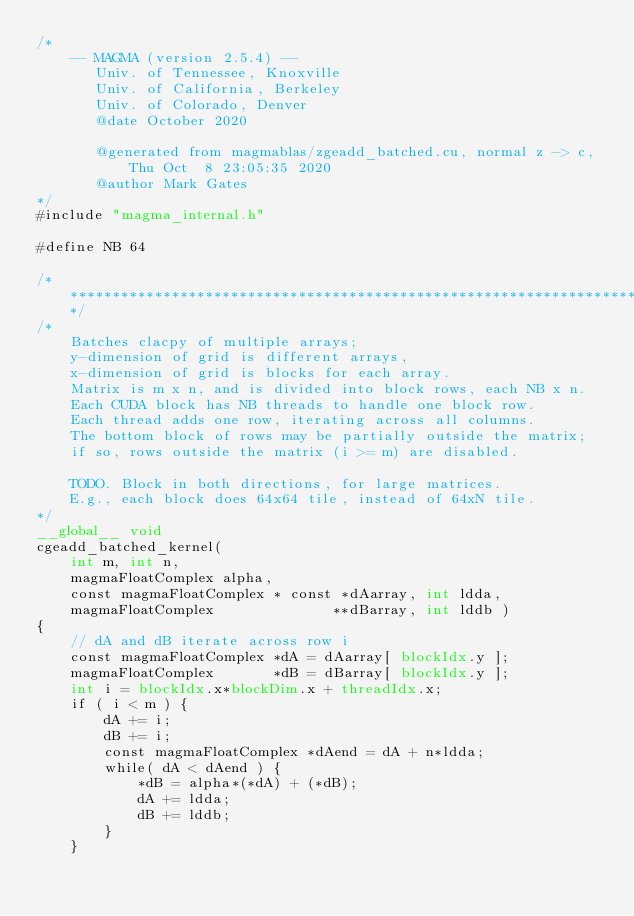Convert code to text. <code><loc_0><loc_0><loc_500><loc_500><_Cuda_>/*
    -- MAGMA (version 2.5.4) --
       Univ. of Tennessee, Knoxville
       Univ. of California, Berkeley
       Univ. of Colorado, Denver
       @date October 2020

       @generated from magmablas/zgeadd_batched.cu, normal z -> c, Thu Oct  8 23:05:35 2020
       @author Mark Gates
*/
#include "magma_internal.h"

#define NB 64

/******************************************************************************/
/*
    Batches clacpy of multiple arrays;
    y-dimension of grid is different arrays,
    x-dimension of grid is blocks for each array.
    Matrix is m x n, and is divided into block rows, each NB x n.
    Each CUDA block has NB threads to handle one block row.
    Each thread adds one row, iterating across all columns.
    The bottom block of rows may be partially outside the matrix;
    if so, rows outside the matrix (i >= m) are disabled.

    TODO. Block in both directions, for large matrices.
    E.g., each block does 64x64 tile, instead of 64xN tile.
*/
__global__ void
cgeadd_batched_kernel(
    int m, int n,
    magmaFloatComplex alpha,
    const magmaFloatComplex * const *dAarray, int ldda,
    magmaFloatComplex              **dBarray, int lddb )
{
    // dA and dB iterate across row i
    const magmaFloatComplex *dA = dAarray[ blockIdx.y ];
    magmaFloatComplex       *dB = dBarray[ blockIdx.y ];
    int i = blockIdx.x*blockDim.x + threadIdx.x;
    if ( i < m ) {
        dA += i;
        dB += i;
        const magmaFloatComplex *dAend = dA + n*ldda;
        while( dA < dAend ) {
            *dB = alpha*(*dA) + (*dB);
            dA += ldda;
            dB += lddb;
        }
    }</code> 